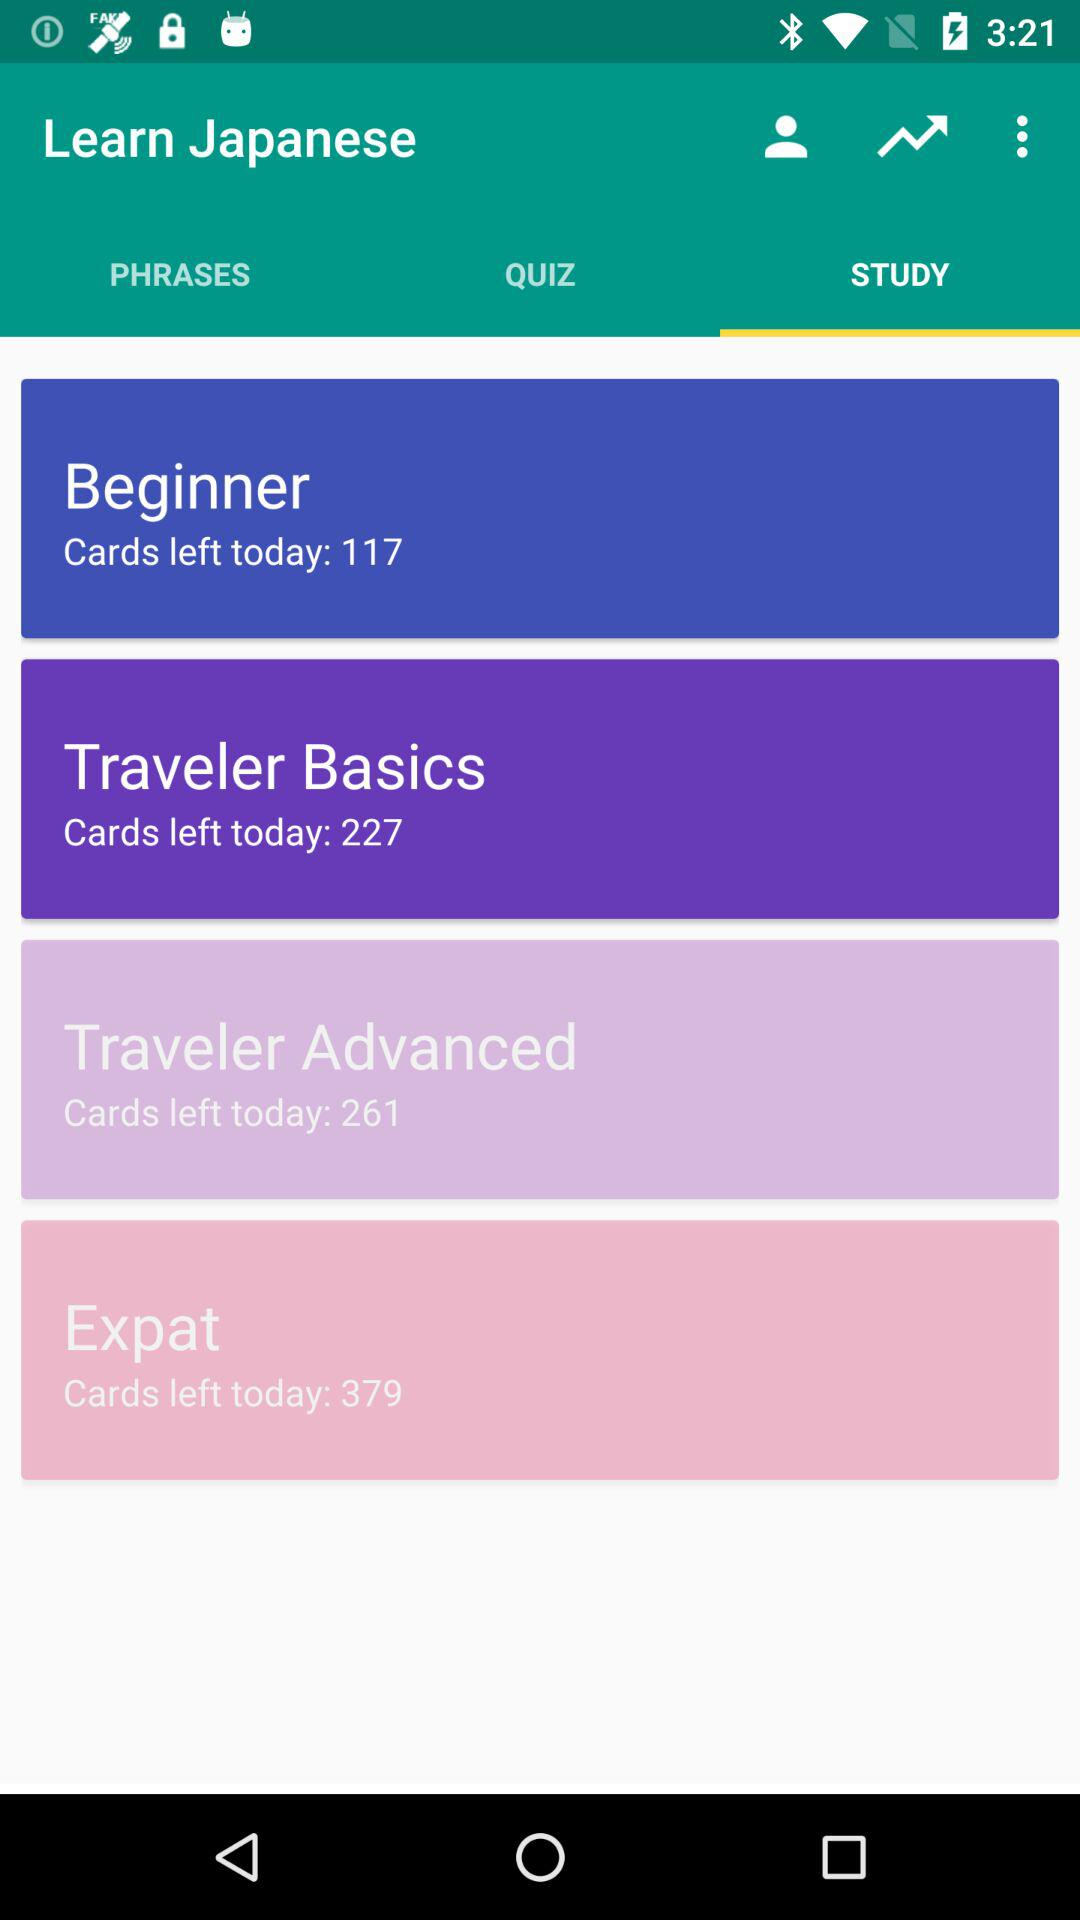Which tab is selected? The selected tab is "STUDY". 